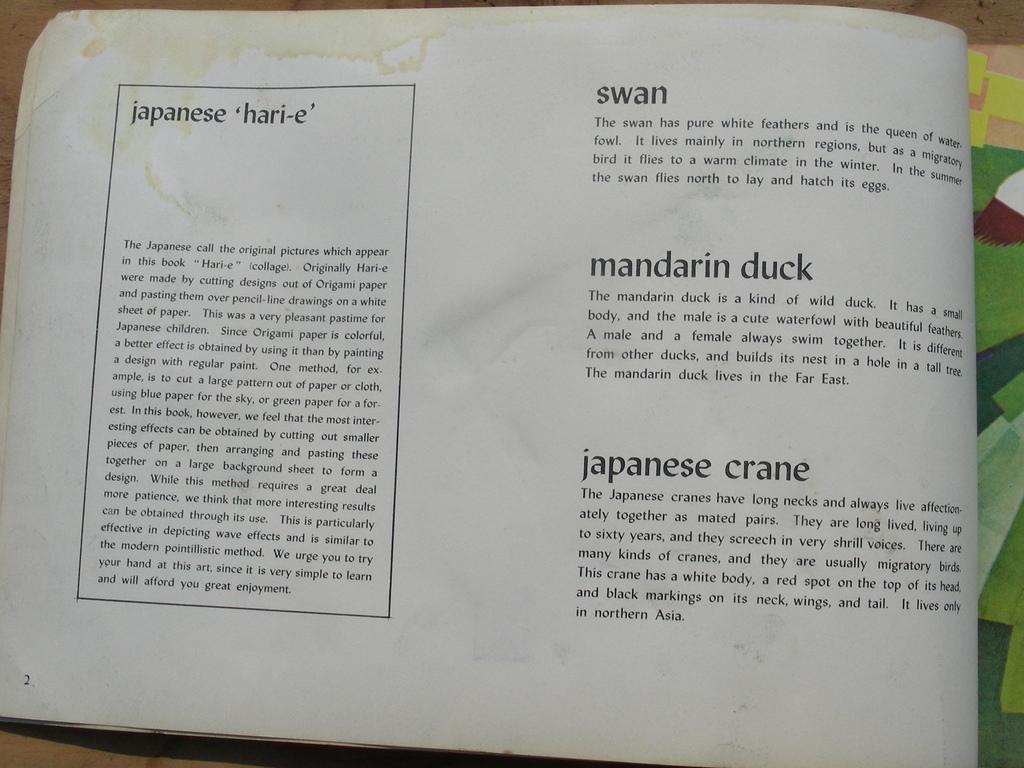Provide a one-sentence caption for the provided image. open book that is stained at top, has paragraphs for swan, mandarin duck, and japanese crane. 